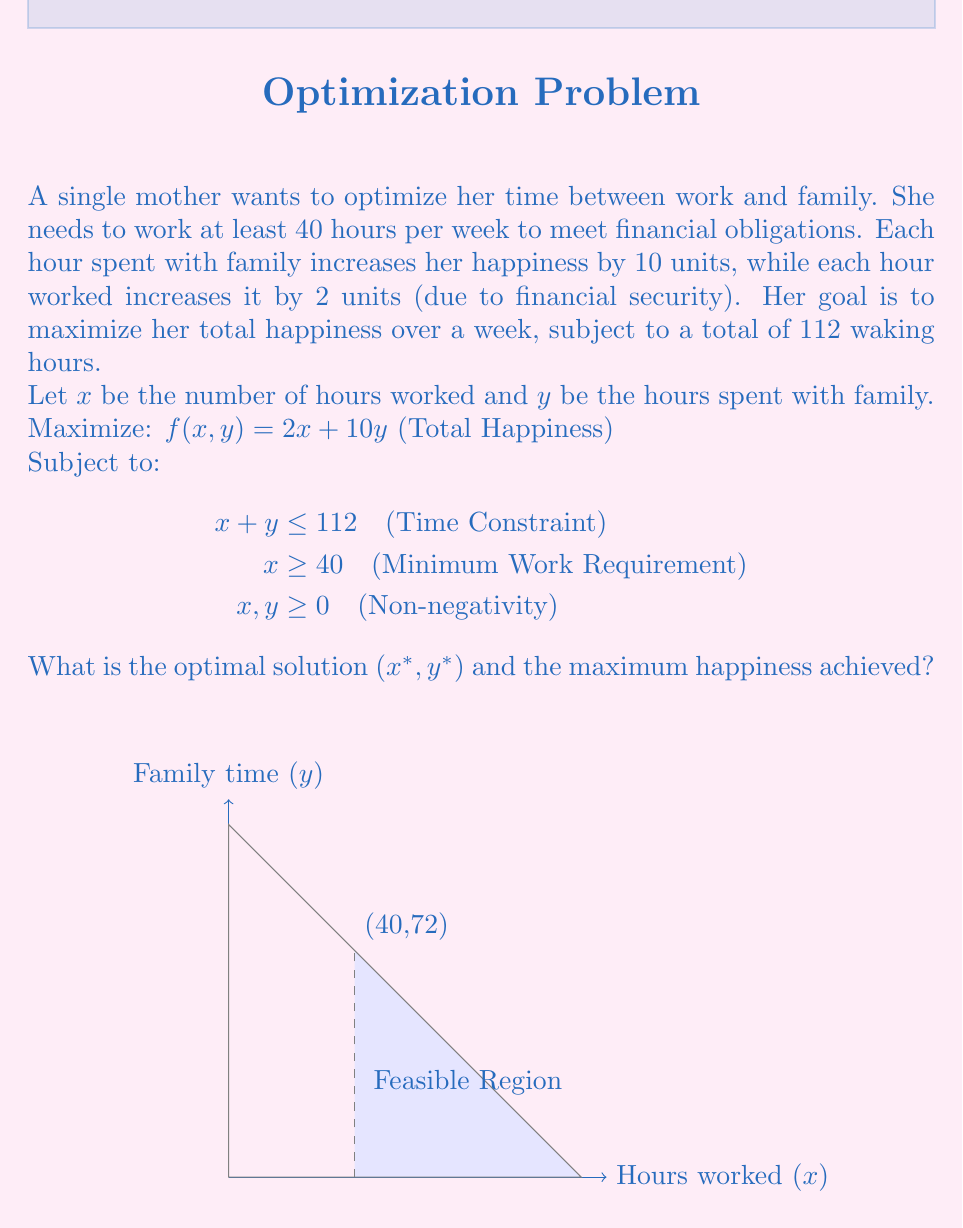Teach me how to tackle this problem. To solve this linear programming problem, we'll use the following steps:

1) Identify the vertices of the feasible region:
   (40,0), (40,72), and (112,0)

2) Evaluate the objective function at each vertex:
   $f(40,0) = 2(40) + 10(0) = 80$
   $f(40,72) = 2(40) + 10(72) = 800$
   $f(112,0) = 2(112) + 10(0) = 224$

3) The maximum value occurs at (40,72), so this is our optimal solution.

Therefore:
$x^* = 40$ (hours worked)
$y^* = 72$ (hours with family)
Maximum happiness = 800 units

This solution suggests that the single mother should work the minimum required 40 hours and spend the remaining 72 hours with her family to maximize her happiness.
Answer: $(x^*, y^*) = (40, 72)$; Maximum happiness = 800 units 